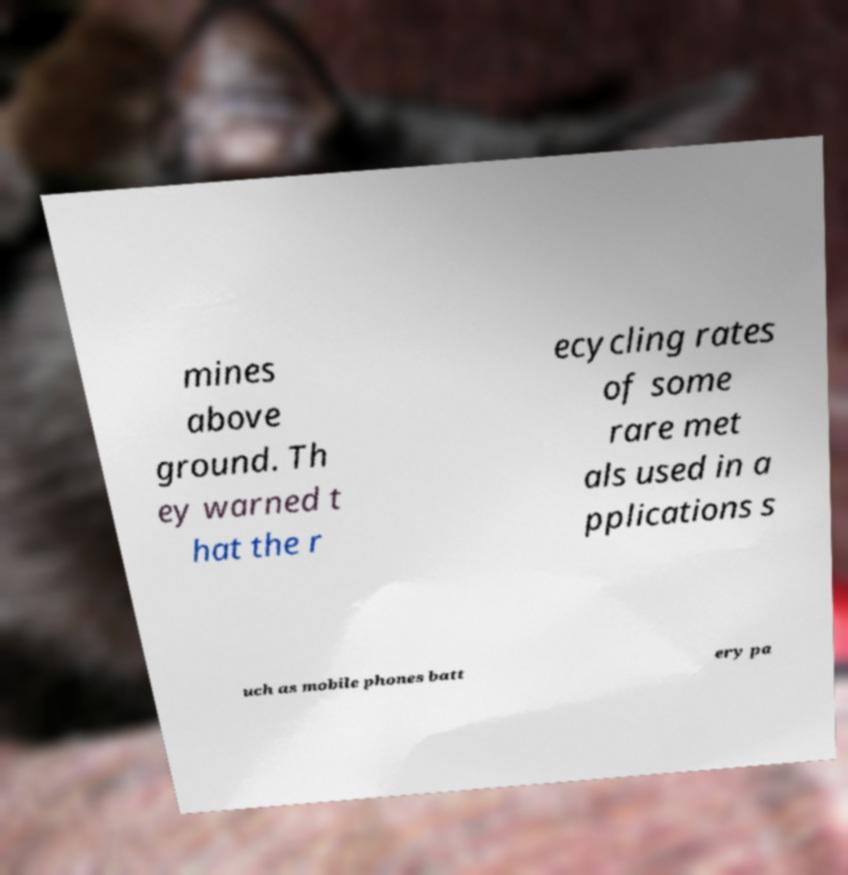I need the written content from this picture converted into text. Can you do that? mines above ground. Th ey warned t hat the r ecycling rates of some rare met als used in a pplications s uch as mobile phones batt ery pa 